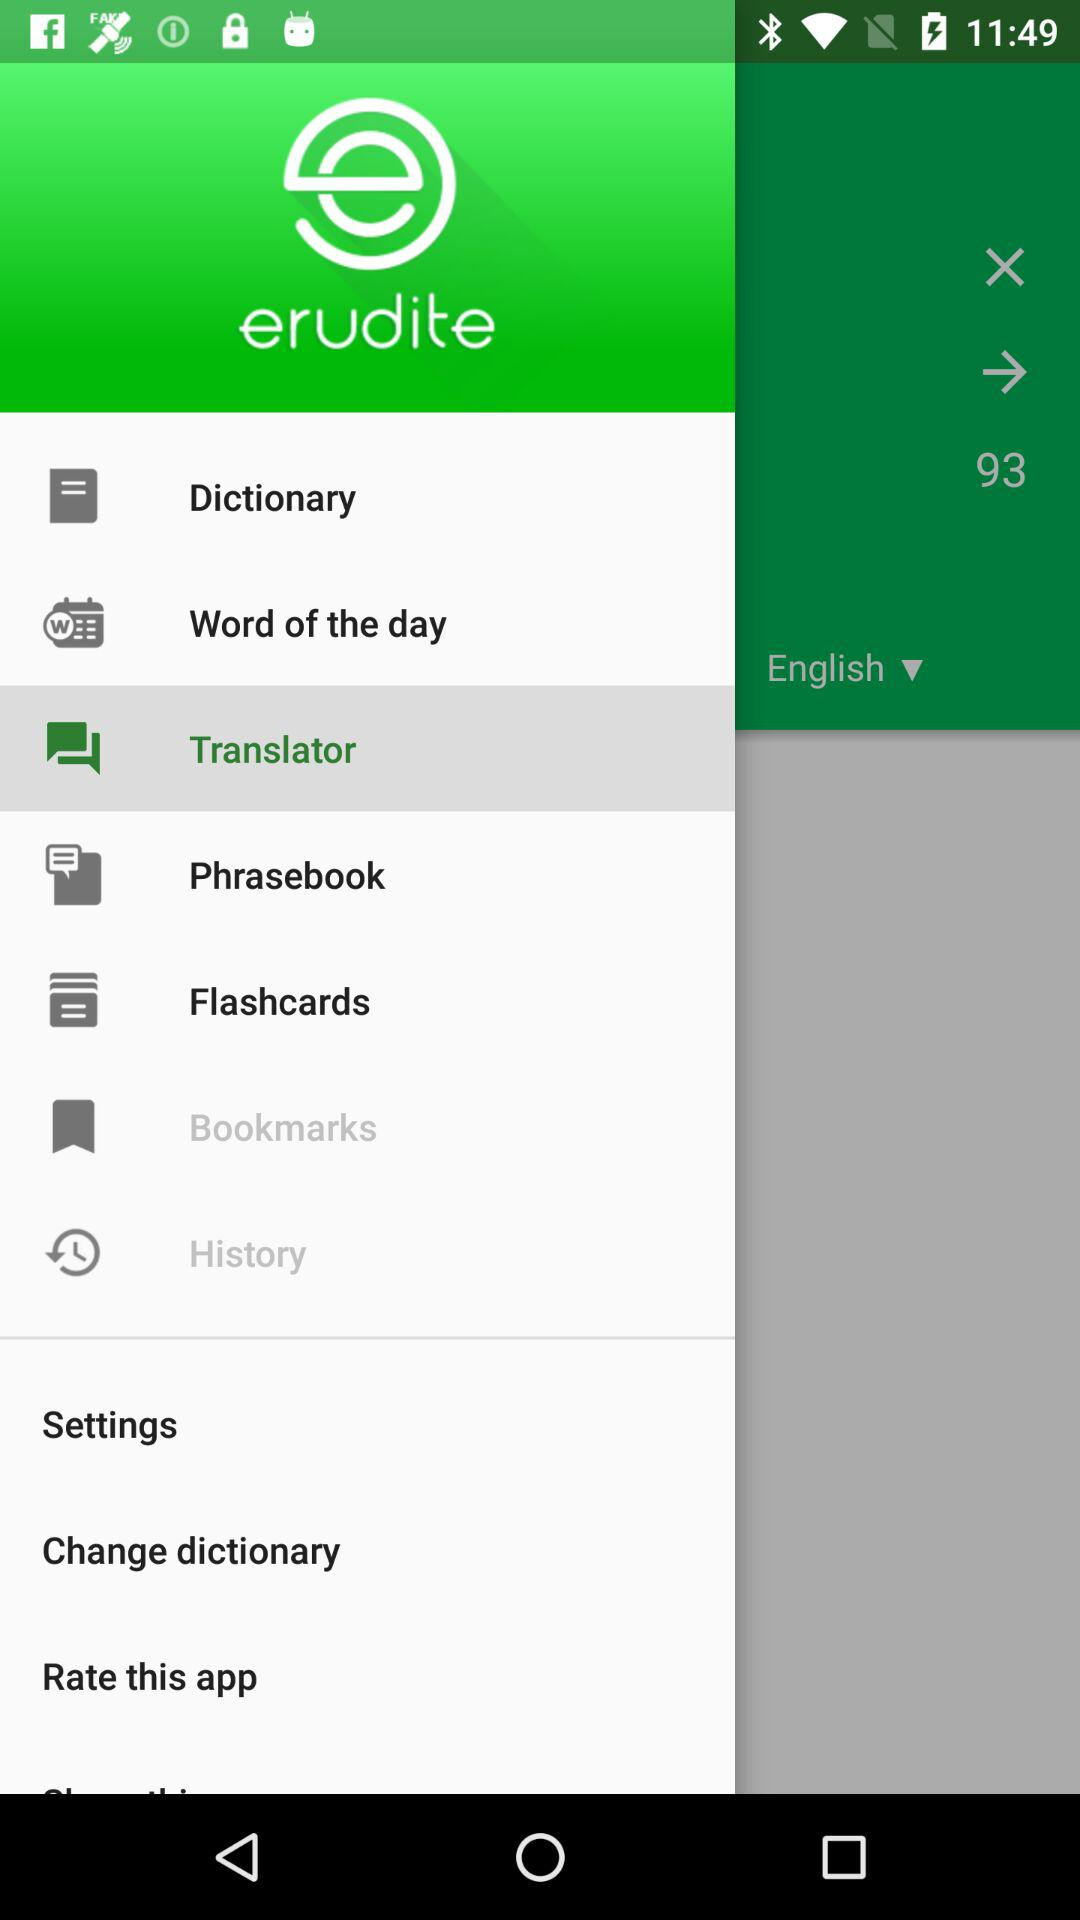How many items are in the history?
When the provided information is insufficient, respond with <no answer>. <no answer> 